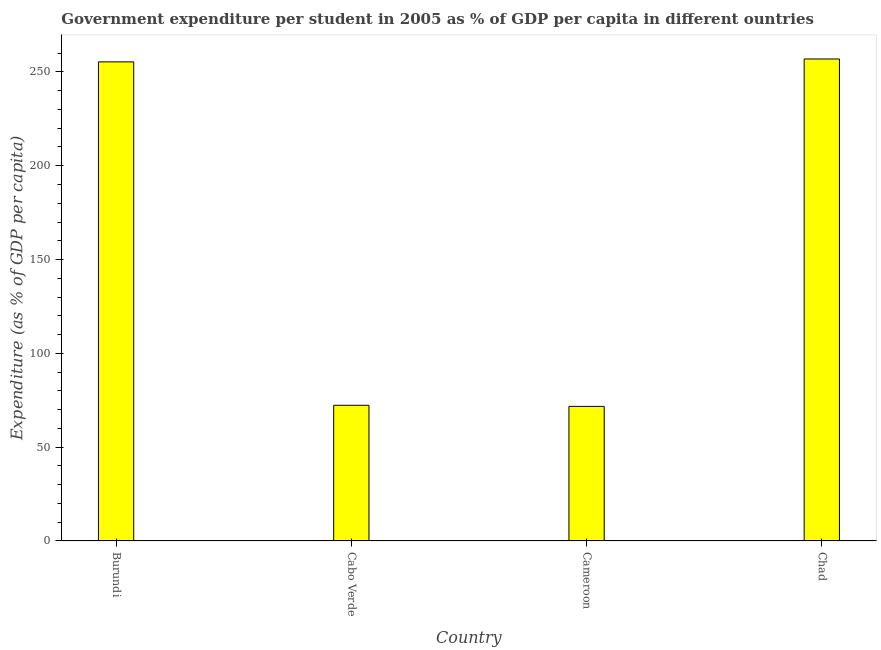What is the title of the graph?
Provide a short and direct response. Government expenditure per student in 2005 as % of GDP per capita in different ountries. What is the label or title of the Y-axis?
Your response must be concise. Expenditure (as % of GDP per capita). What is the government expenditure per student in Burundi?
Ensure brevity in your answer.  255.38. Across all countries, what is the maximum government expenditure per student?
Your answer should be very brief. 256.93. Across all countries, what is the minimum government expenditure per student?
Offer a terse response. 71.72. In which country was the government expenditure per student maximum?
Your response must be concise. Chad. In which country was the government expenditure per student minimum?
Offer a very short reply. Cameroon. What is the sum of the government expenditure per student?
Make the answer very short. 656.34. What is the difference between the government expenditure per student in Cabo Verde and Cameroon?
Provide a short and direct response. 0.59. What is the average government expenditure per student per country?
Keep it short and to the point. 164.08. What is the median government expenditure per student?
Provide a succinct answer. 163.85. What is the ratio of the government expenditure per student in Burundi to that in Cabo Verde?
Make the answer very short. 3.53. Is the government expenditure per student in Burundi less than that in Chad?
Provide a short and direct response. Yes. Is the difference between the government expenditure per student in Burundi and Chad greater than the difference between any two countries?
Make the answer very short. No. What is the difference between the highest and the second highest government expenditure per student?
Give a very brief answer. 1.54. What is the difference between the highest and the lowest government expenditure per student?
Your answer should be compact. 185.21. In how many countries, is the government expenditure per student greater than the average government expenditure per student taken over all countries?
Give a very brief answer. 2. How many bars are there?
Offer a terse response. 4. Are all the bars in the graph horizontal?
Your response must be concise. No. How many countries are there in the graph?
Offer a terse response. 4. Are the values on the major ticks of Y-axis written in scientific E-notation?
Your response must be concise. No. What is the Expenditure (as % of GDP per capita) in Burundi?
Keep it short and to the point. 255.38. What is the Expenditure (as % of GDP per capita) in Cabo Verde?
Offer a very short reply. 72.31. What is the Expenditure (as % of GDP per capita) in Cameroon?
Ensure brevity in your answer.  71.72. What is the Expenditure (as % of GDP per capita) in Chad?
Your response must be concise. 256.93. What is the difference between the Expenditure (as % of GDP per capita) in Burundi and Cabo Verde?
Make the answer very short. 183.07. What is the difference between the Expenditure (as % of GDP per capita) in Burundi and Cameroon?
Your response must be concise. 183.66. What is the difference between the Expenditure (as % of GDP per capita) in Burundi and Chad?
Your answer should be very brief. -1.54. What is the difference between the Expenditure (as % of GDP per capita) in Cabo Verde and Cameroon?
Your answer should be very brief. 0.59. What is the difference between the Expenditure (as % of GDP per capita) in Cabo Verde and Chad?
Provide a short and direct response. -184.61. What is the difference between the Expenditure (as % of GDP per capita) in Cameroon and Chad?
Provide a short and direct response. -185.21. What is the ratio of the Expenditure (as % of GDP per capita) in Burundi to that in Cabo Verde?
Your answer should be very brief. 3.53. What is the ratio of the Expenditure (as % of GDP per capita) in Burundi to that in Cameroon?
Make the answer very short. 3.56. What is the ratio of the Expenditure (as % of GDP per capita) in Cabo Verde to that in Chad?
Give a very brief answer. 0.28. What is the ratio of the Expenditure (as % of GDP per capita) in Cameroon to that in Chad?
Ensure brevity in your answer.  0.28. 